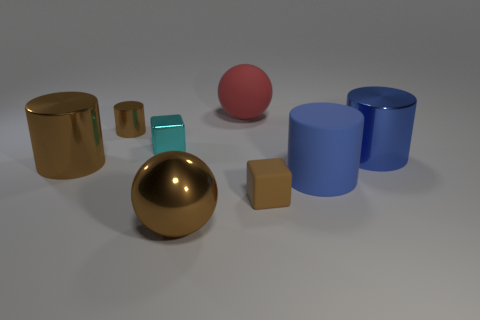Subtract all small cylinders. How many cylinders are left? 3 Add 1 yellow spheres. How many objects exist? 9 Subtract all blue cylinders. How many cylinders are left? 2 Subtract 1 spheres. How many spheres are left? 1 Subtract all yellow balls. How many red cylinders are left? 0 Subtract all large shiny cylinders. Subtract all big green metallic cubes. How many objects are left? 6 Add 6 big brown shiny spheres. How many big brown shiny spheres are left? 7 Add 4 yellow metallic balls. How many yellow metallic balls exist? 4 Subtract 0 purple cubes. How many objects are left? 8 Subtract all balls. How many objects are left? 6 